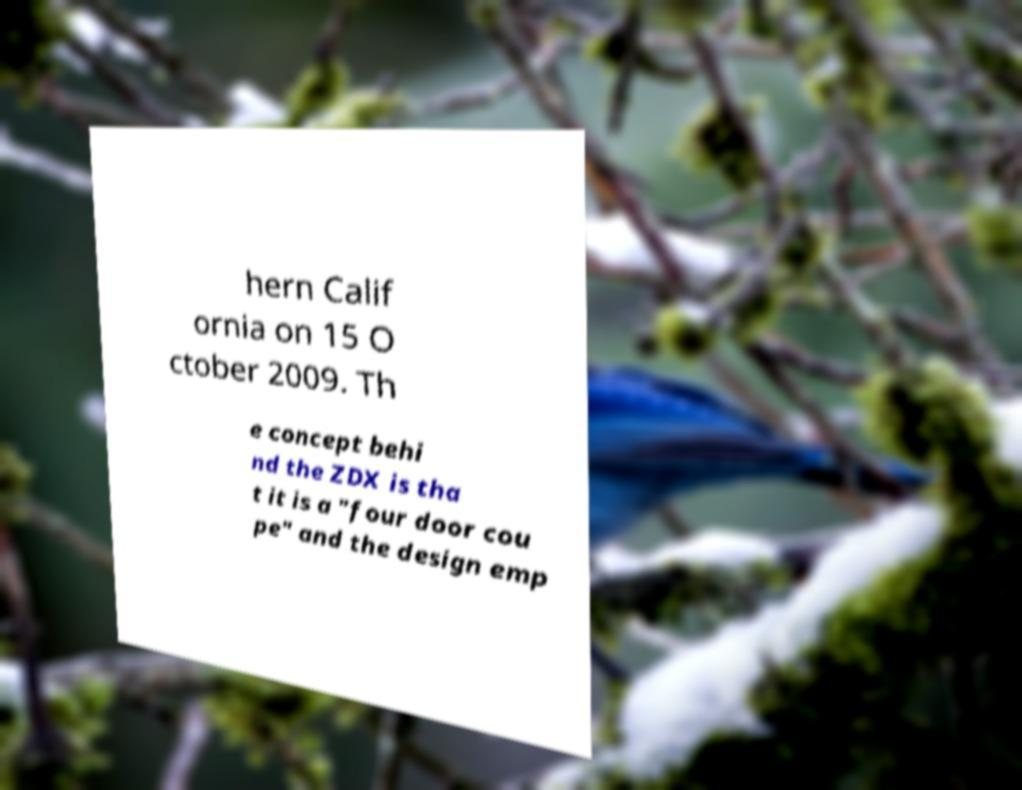Please read and relay the text visible in this image. What does it say? hern Calif ornia on 15 O ctober 2009. Th e concept behi nd the ZDX is tha t it is a "four door cou pe" and the design emp 